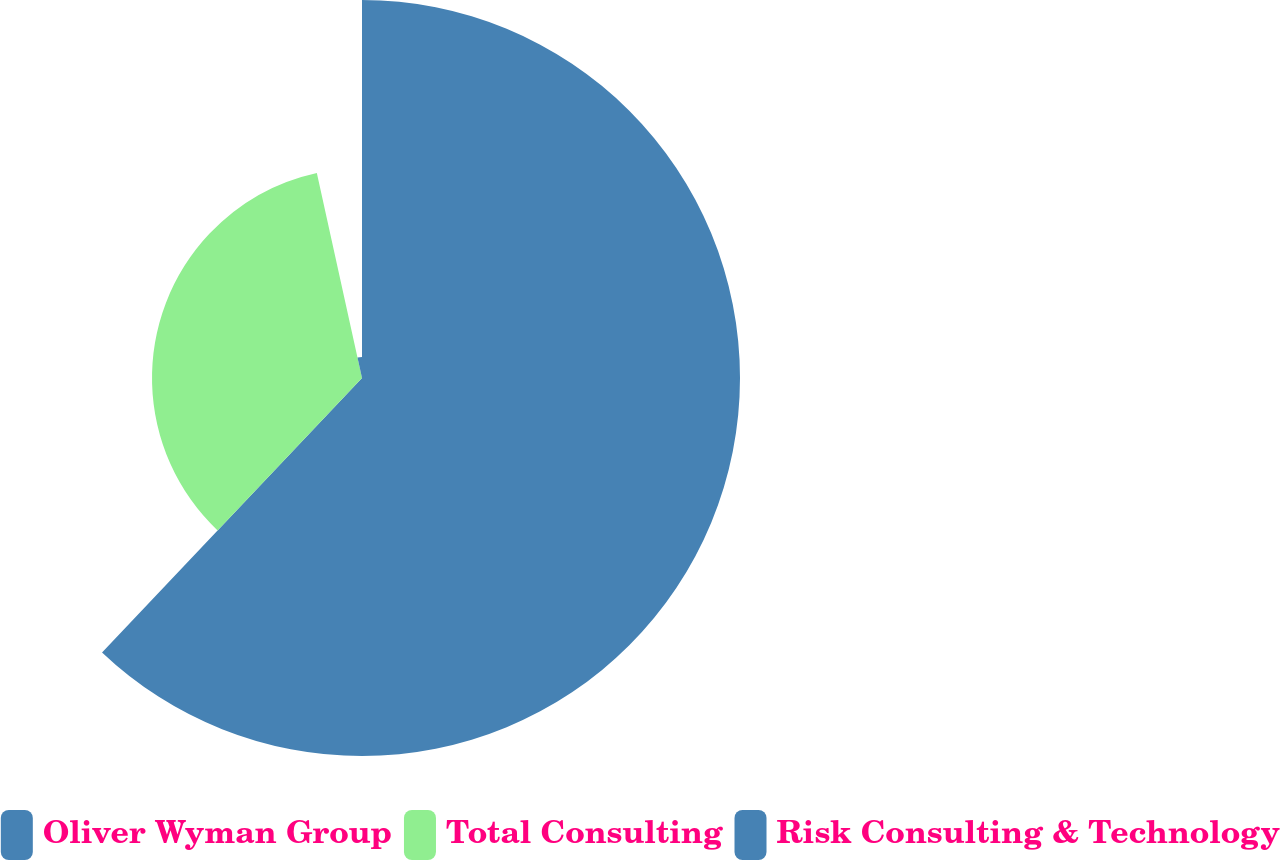Convert chart. <chart><loc_0><loc_0><loc_500><loc_500><pie_chart><fcel>Oliver Wyman Group<fcel>Total Consulting<fcel>Risk Consulting & Technology<nl><fcel>62.07%<fcel>34.48%<fcel>3.45%<nl></chart> 